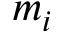<formula> <loc_0><loc_0><loc_500><loc_500>m _ { i }</formula> 